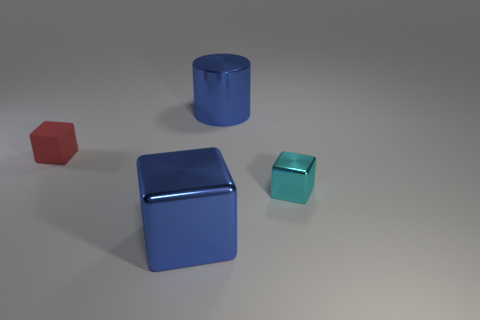Are there any other things that are the same color as the matte object?
Your answer should be very brief. No. There is a small thing right of the red matte block; is its shape the same as the matte thing that is behind the blue block?
Offer a terse response. Yes. There is a shiny thing that is the same color as the large block; what shape is it?
Offer a terse response. Cylinder. What number of other cubes are the same material as the red cube?
Your answer should be very brief. 0. There is a object that is both behind the cyan block and on the right side of the matte thing; what shape is it?
Offer a very short reply. Cylinder. Does the large thing that is behind the red matte block have the same material as the red cube?
Your answer should be compact. No. Are there any other things that are the same material as the small red cube?
Your answer should be compact. No. The metallic thing that is the same size as the cylinder is what color?
Offer a terse response. Blue. Is there a big block of the same color as the large cylinder?
Provide a short and direct response. Yes. The blue object that is the same material as the large cylinder is what size?
Provide a short and direct response. Large. 